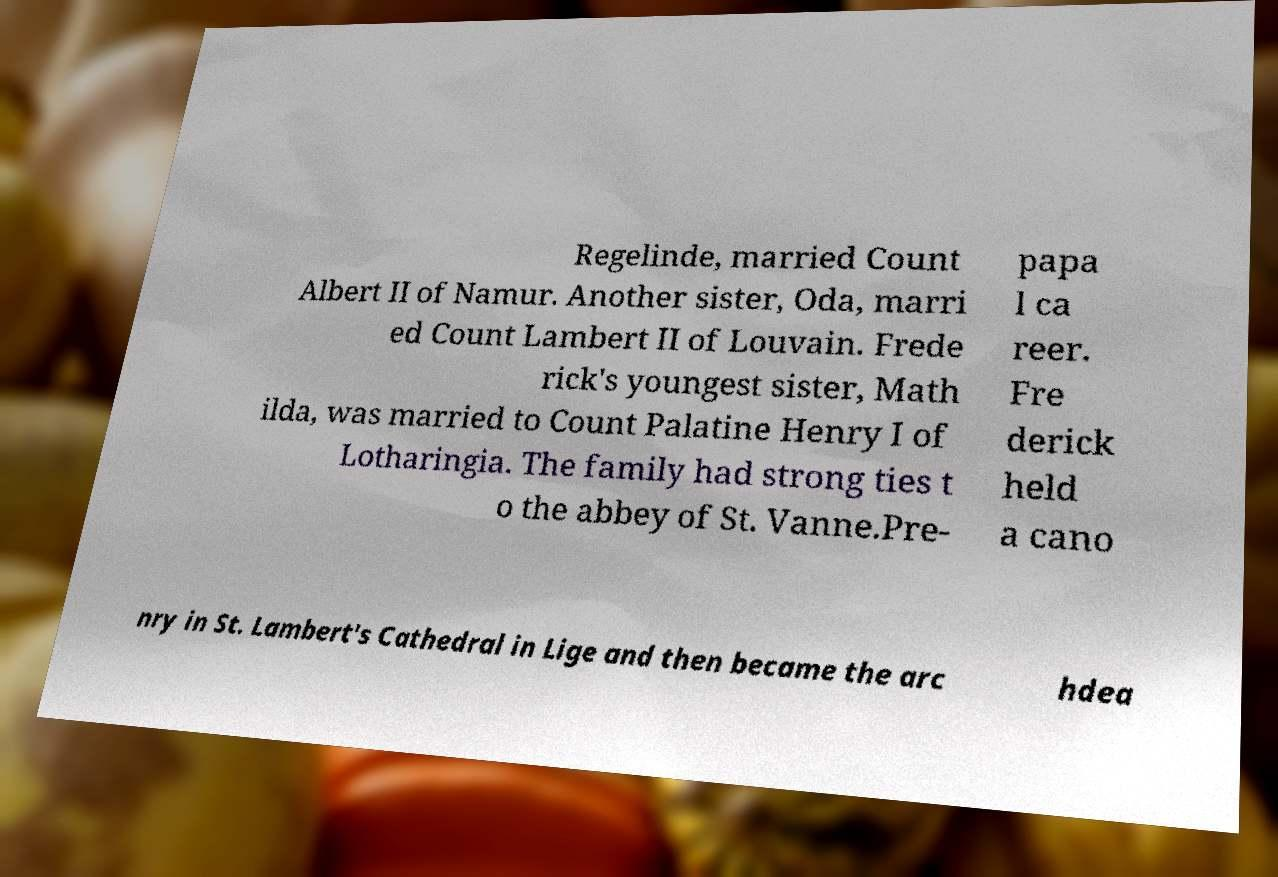What messages or text are displayed in this image? I need them in a readable, typed format. Regelinde, married Count Albert II of Namur. Another sister, Oda, marri ed Count Lambert II of Louvain. Frede rick's youngest sister, Math ilda, was married to Count Palatine Henry I of Lotharingia. The family had strong ties t o the abbey of St. Vanne.Pre- papa l ca reer. Fre derick held a cano nry in St. Lambert's Cathedral in Lige and then became the arc hdea 